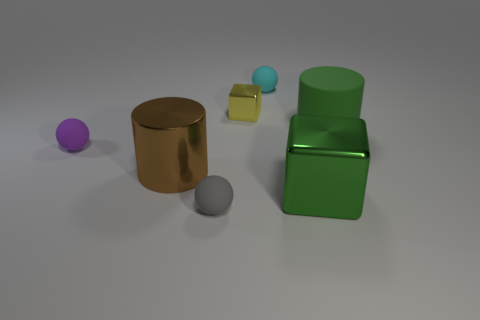Can you describe the lighting in this scene? The lighting in the scene appears soft and diffuse, with shadows indicating a light source coming from the upper left side. The gentle lighting creates a calm mood and gives the objects soft shadows, enhancing their three-dimensional forms. 